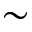Convert formula to latex. <formula><loc_0><loc_0><loc_500><loc_500>\sim</formula> 